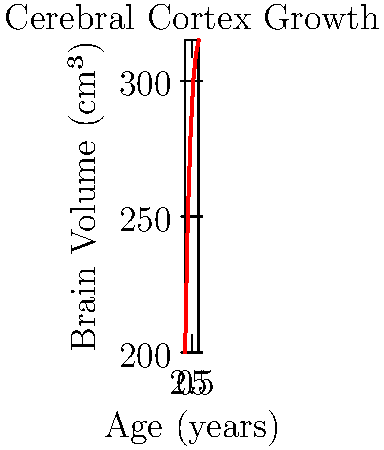Based on the time-series growth chart of cerebral cortex volume, at which age range does the most significant developmental milestone in brain growth likely occur? To determine the age range with the most significant developmental milestone in brain growth, we need to analyze the rate of change in cerebral cortex volume over time:

1. Calculate the change in volume for each year:
   0-1 years: 250 - 200 = 50 cm³
   1-2 years: 280 - 250 = 30 cm³
   2-3 years: 300 - 280 = 20 cm³
   3-4 years: 310 - 300 = 10 cm³
   4-5 years: 315 - 310 = 5 cm³

2. Identify the largest change:
   The largest change is 50 cm³, occurring between 0-1 years.

3. Consider the biological significance:
   Rapid brain growth in the first year of life is associated with critical developmental milestones such as improved sensory processing, motor skills, and cognitive functions.

4. Evaluate the curve shape:
   The steepest slope of the curve is observed between 0-1 years, indicating the fastest growth rate.

5. Compare to known neurological development:
   The first year of life is crucial for synaptic formation, myelination, and overall brain plasticity, aligning with the observed rapid growth.

Therefore, the most significant developmental milestone in brain growth likely occurs in the 0-1 year age range.
Answer: 0-1 years 